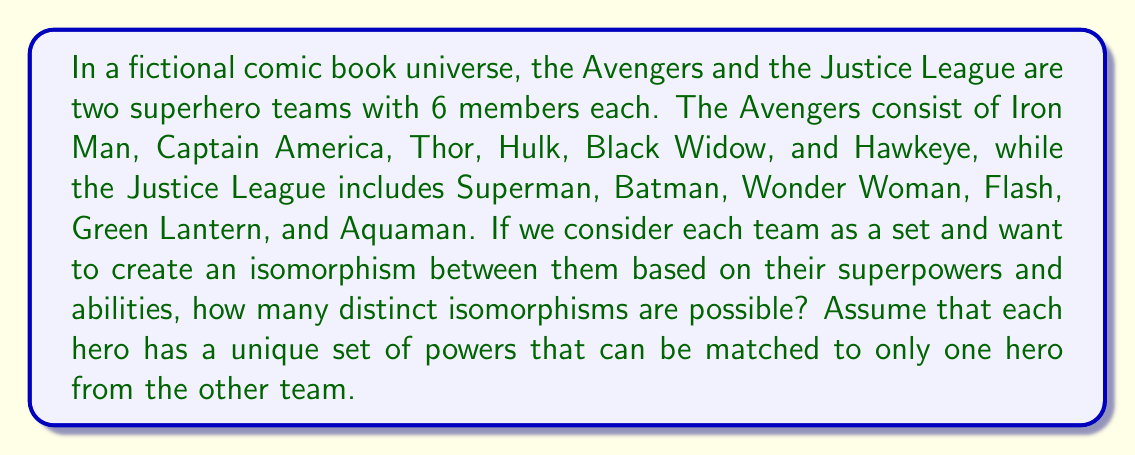Show me your answer to this math problem. To solve this problem, we need to understand that an isomorphism between two sets is a bijective function that preserves the structure of the sets. In this case, we're looking at the number of ways to create a one-to-one correspondence between the members of the Avengers and the Justice League based on their powers.

Let's approach this step-by-step:

1) First, we need to recognize that this is essentially a permutation problem. We're asking in how many ways we can arrange the 6 Justice League members to correspond to the 6 Avengers members.

2) In permutation problems, the number of ways to arrange n distinct objects is given by n!.

3) In this case, we have 6 heroes in each team, so we're looking at 6! permutations.

4) Let's calculate 6!:

   $$6! = 6 \times 5 \times 4 \times 3 \times 2 \times 1 = 720$$

5) Each of these 720 permutations represents a unique way to match the heroes from one team to the other, and thus, a unique isomorphism between the two teams.

This problem is analogous to the number of isomorphisms between two groups of order 6, where each element in one group corresponds uniquely to an element in the other group. In group theory, this is known as the number of automorphisms of a group of order 6, which is indeed 6! = 720.
Answer: There are 720 distinct isomorphisms possible between the Avengers and the Justice League teams. 